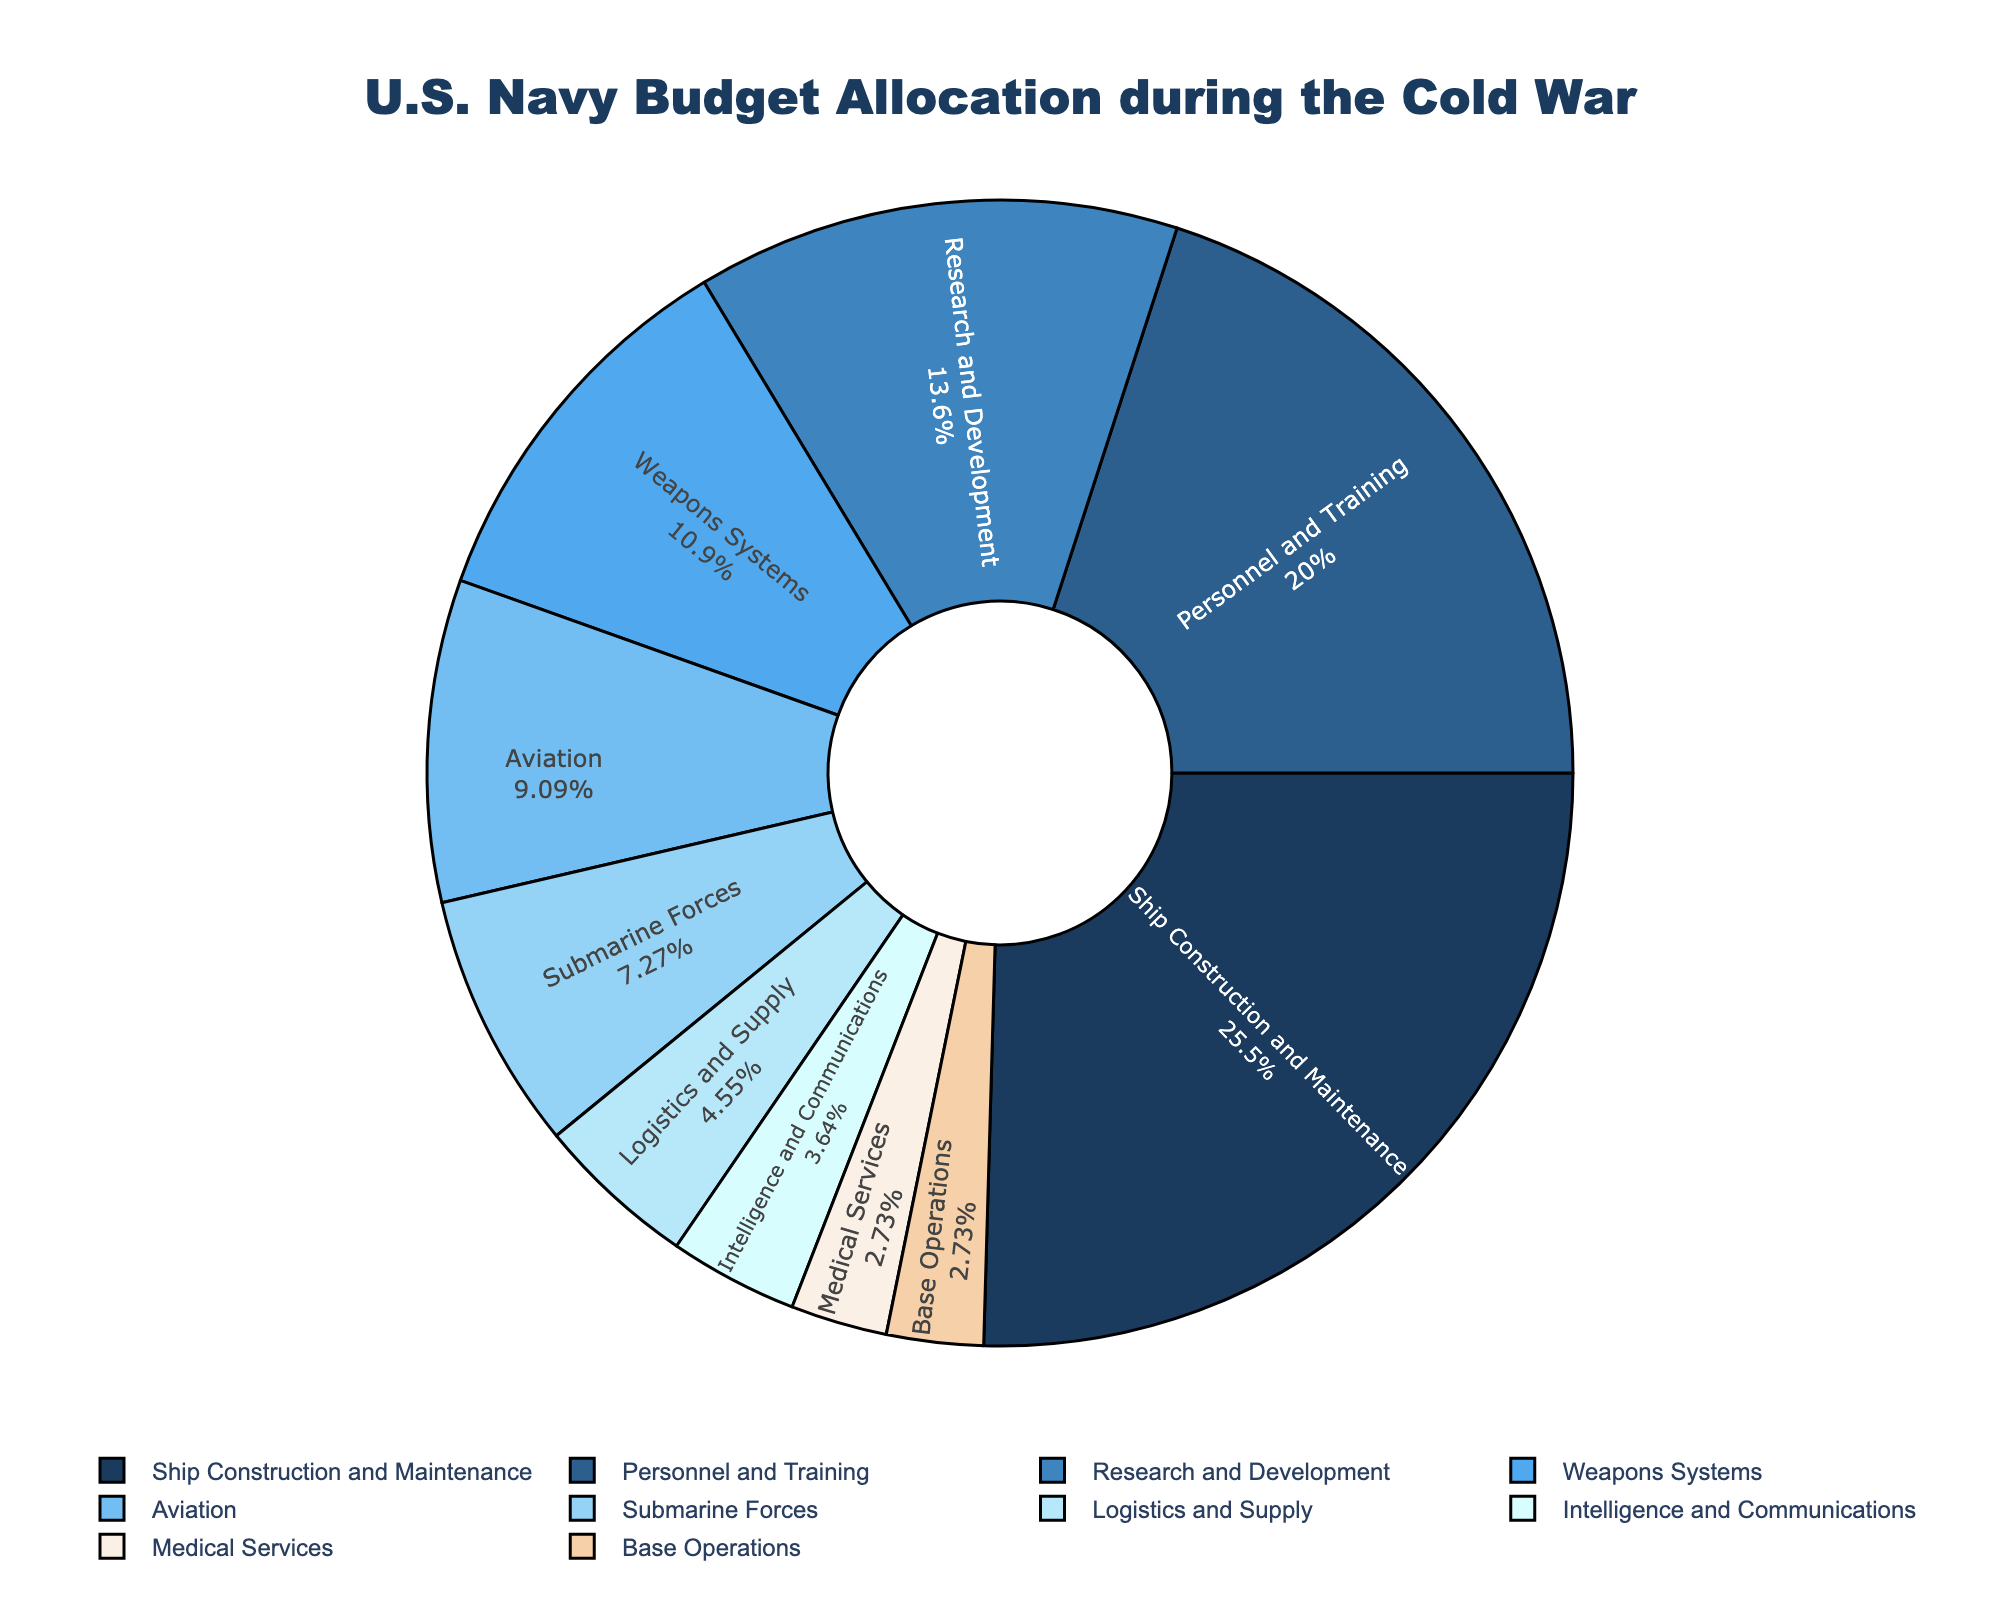What are the two departments with the highest budget allocation? The pie chart visually shows the allocation of the naval budget among different departments with labeled percentages. The departments with the highest allocation are Ship Construction and Maintenance and Personnel and Training with 28% and 22% respectively.
Answer: Ship Construction and Maintenance, Personnel and Training What's the combined budget percentage for Aviation and Submarine Forces? The percentage of the budget allocated to Aviation is 10%, and to Submarine Forces is 8%. Adding these together gives 10% + 8% = 18%.
Answer: 18% Is the allocation for Research and Development greater than that for Weapons Systems? The pie chart shows Research and Development at 15% and Weapons Systems at 12%. Since 15% is greater than 12%, Research and Development has a higher allocation.
Answer: Yes Which department has the lowest budget allocation, and what is its percentage? Among all the departments listed on the pie chart, Medical Services and Base Operations have the lowest budget allocations, both with 3%.
Answer: Medical Services, Base Operations (3% each) What percentage of the budget is allocated to departments labeled as Logistics and Supply and Intelligence and Communications combined? The pie chart provides 5% for Logistics and Supply and 4% for Intelligence and Communications. Adding these two figures together results in 5% + 4% = 9%.
Answer: 9% Compare the budget allocated for Medical Services to Base Operations. Which one has more? Both Medical Services and Base Operations are allocated an equal budget percentage of 3% each according to the pie chart.
Answer: Equal What is the total percentage allocated to Personnel and Training, Medical Services, and Base Operations together? Summing the percentages given in the pie chart for Personnel and Training (22%), Medical Services (3%), and Base Operations (3%) gives 22% + 3% + 3% = 28%.
Answer: 28% How does the allocation for Ship Construction and Maintenance compare to Research and Development? Looking at the pie chart, Ship Construction and Maintenance is allocated 28% of the budget, while Research and Development is allocated 15%. Ship Construction and Maintenance thus has a larger percentage.
Answer: Ship Construction and Maintenance has more What is the difference in budget allocation between the department with the highest percentage and the department with the lowest? Ship Construction and Maintenance has the highest allocation at 28%. Both Medical Services and Base Operations have the lowest allocation at 3%. The difference is 28% - 3% = 25%.
Answer: 25% 